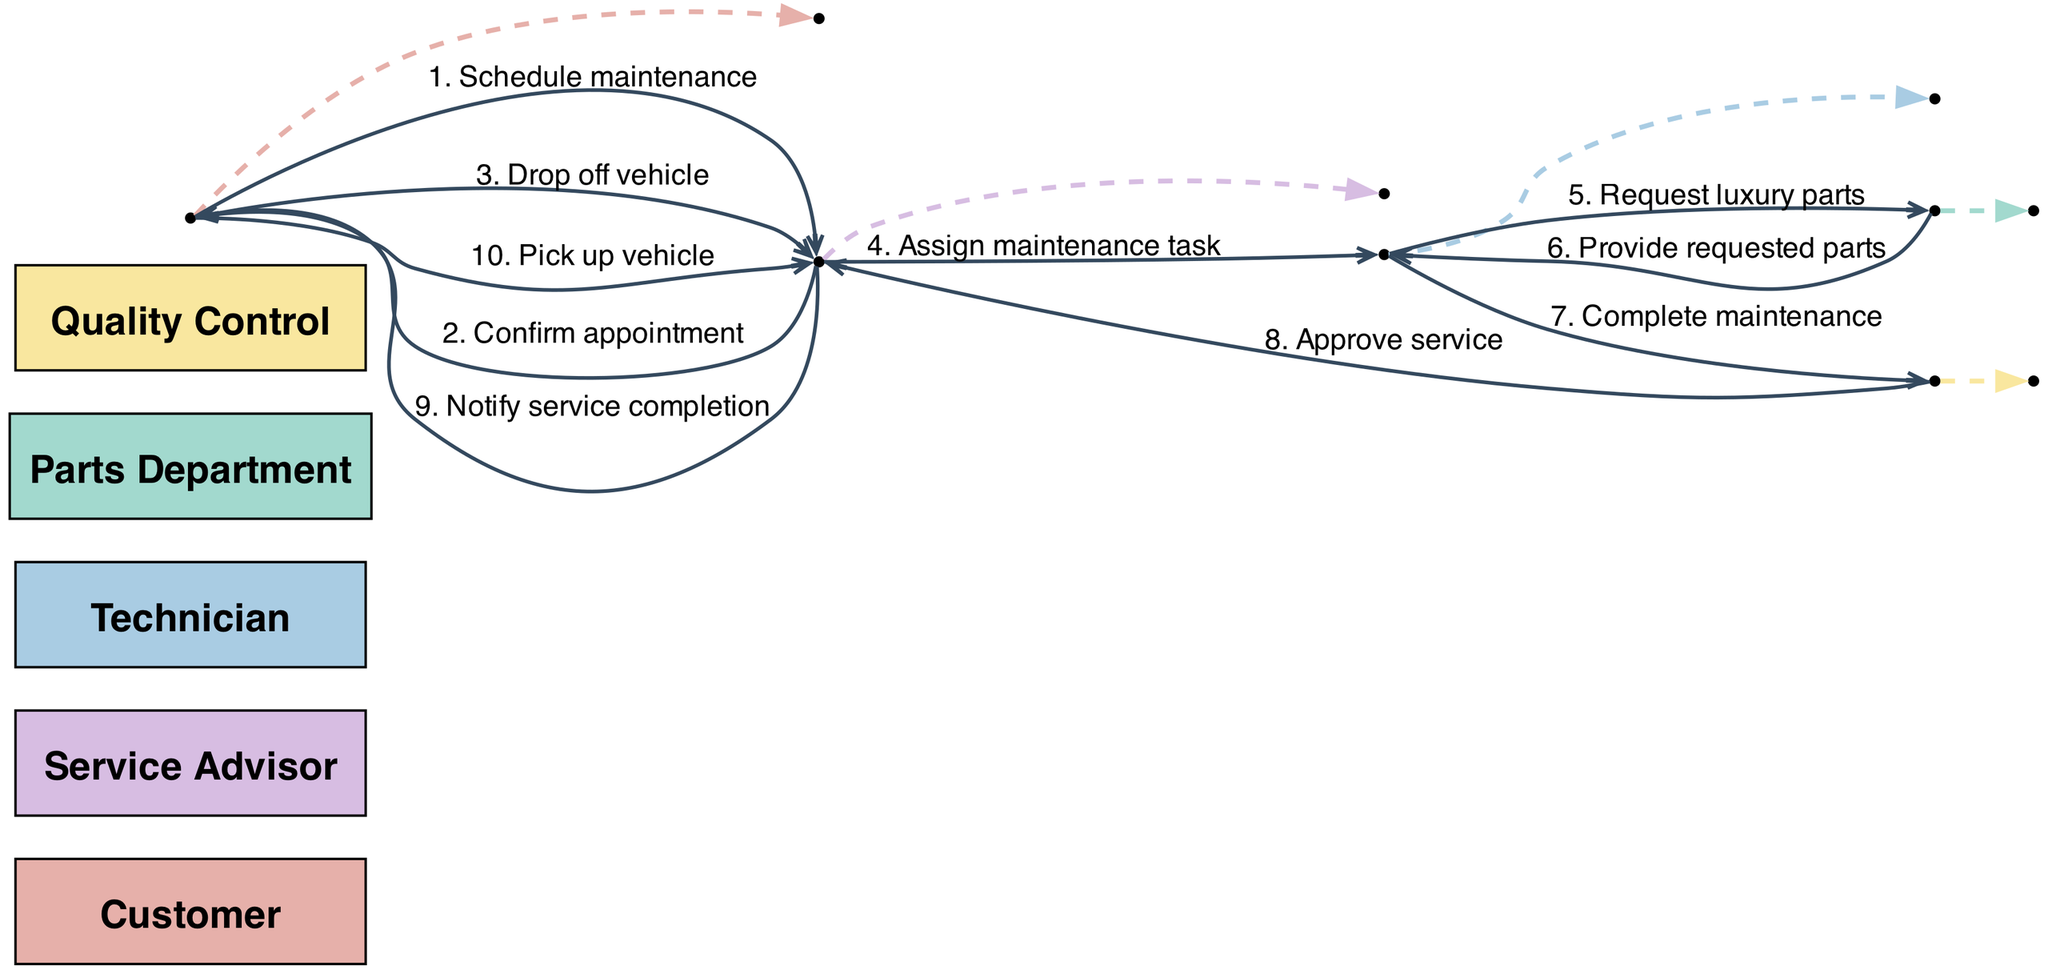What is the first interaction in the sequence? The first interaction in the sequence is between the Customer and the Service Advisor, where the Customer initiates the action by scheduling maintenance.
Answer: Schedule maintenance How many actors are involved in this diagram? There are five actors involved in the diagram: Customer, Service Advisor, Technician, Parts Department, and Quality Control.
Answer: Five Who confirms the appointment to the Customer? The Service Advisor is responsible for confirming the appointment back to the Customer after the scheduling request.
Answer: Service Advisor What is the message from the Technician to the Parts Department? The Technician requests luxury parts from the Parts Department, asking for the necessary items to perform the maintenance task.
Answer: Request luxury parts Which actor notifies the Customer of service completion? The Service Advisor is the actor that notifies the Customer once the service is complete and ready for vehicle pickup.
Answer: Service Advisor What is the last step in the maintenance process? The last step in the maintenance process is the Customer picking up the vehicle after being notified by the Service Advisor about the service completion.
Answer: Pick up vehicle Which actor interacts with Quality Control before the service approval? The Technician interacts with Quality Control after completing the maintenance, reporting the request for service approval.
Answer: Technician How many messages are exchanged between the Service Advisor and the Customer? There are three messages exchanged between the Service Advisor and the Customer: scheduling maintenance, confirming the appointment, and notifying service completion.
Answer: Three What role does the Parts Department play in this process? The Parts Department provides the requested luxury parts to the Technician, facilitating the maintenance process.
Answer: Provide requested parts 